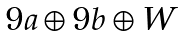Convert formula to latex. <formula><loc_0><loc_0><loc_500><loc_500>\begin{matrix} \\ 9 a \oplus 9 b \oplus W \\ \end{matrix}</formula> 